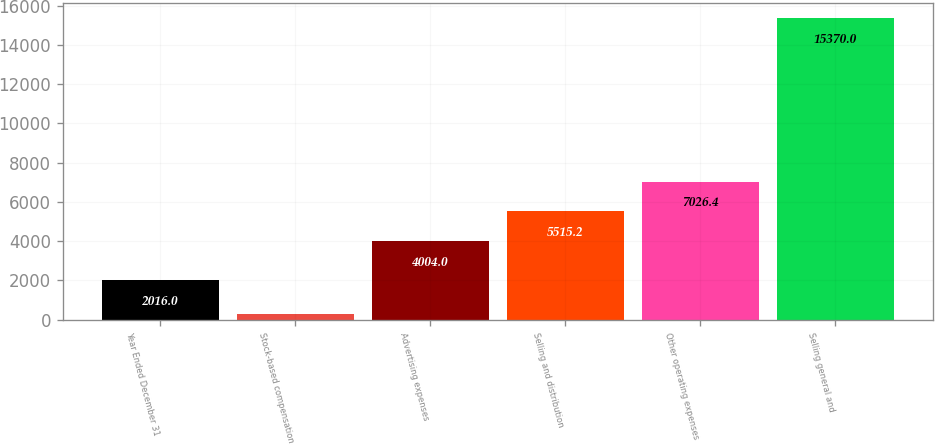<chart> <loc_0><loc_0><loc_500><loc_500><bar_chart><fcel>Year Ended December 31<fcel>Stock-based compensation<fcel>Advertising expenses<fcel>Selling and distribution<fcel>Other operating expenses<fcel>Selling general and<nl><fcel>2016<fcel>258<fcel>4004<fcel>5515.2<fcel>7026.4<fcel>15370<nl></chart> 